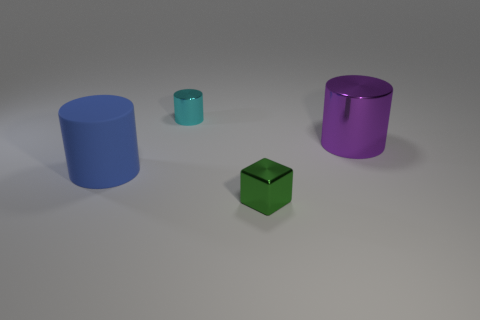How do the objects appear in terms of material? The objects in the image seem to be made of different materials with varying textures. The blue and purple cylinders have a smooth, possibly metallic surface, reflecting light and giving off a subtle shine. The small teal object seems to have a matte finish, while the green cube appears slightly translucent, suggesting it could be made of colored glass or a similar material. 